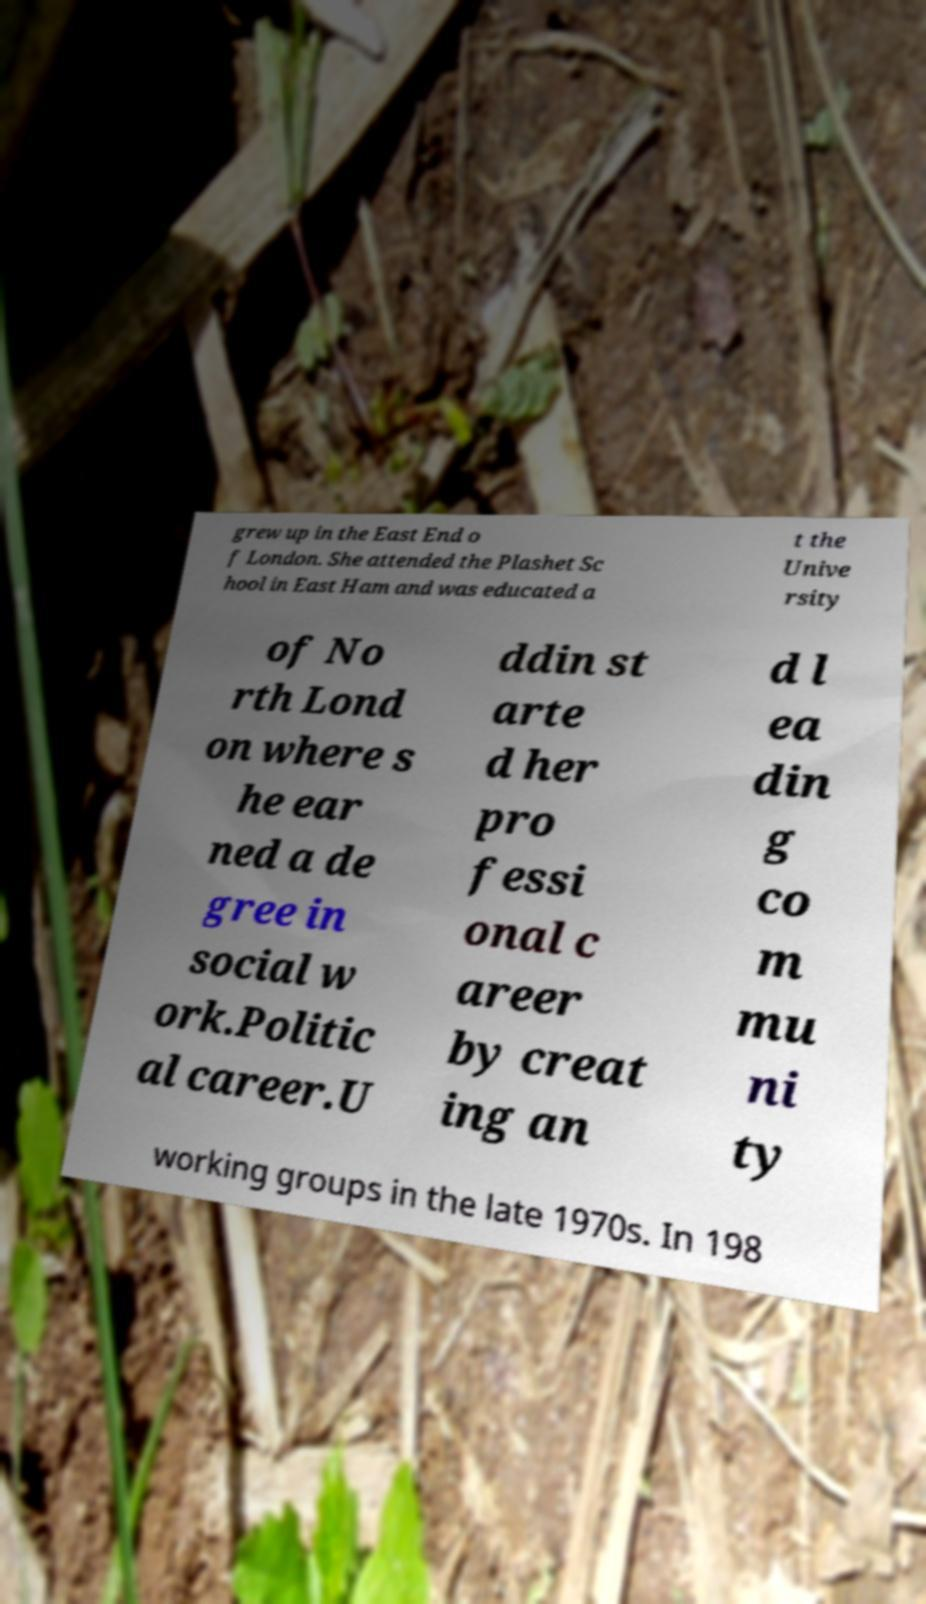Could you assist in decoding the text presented in this image and type it out clearly? grew up in the East End o f London. She attended the Plashet Sc hool in East Ham and was educated a t the Unive rsity of No rth Lond on where s he ear ned a de gree in social w ork.Politic al career.U ddin st arte d her pro fessi onal c areer by creat ing an d l ea din g co m mu ni ty working groups in the late 1970s. In 198 